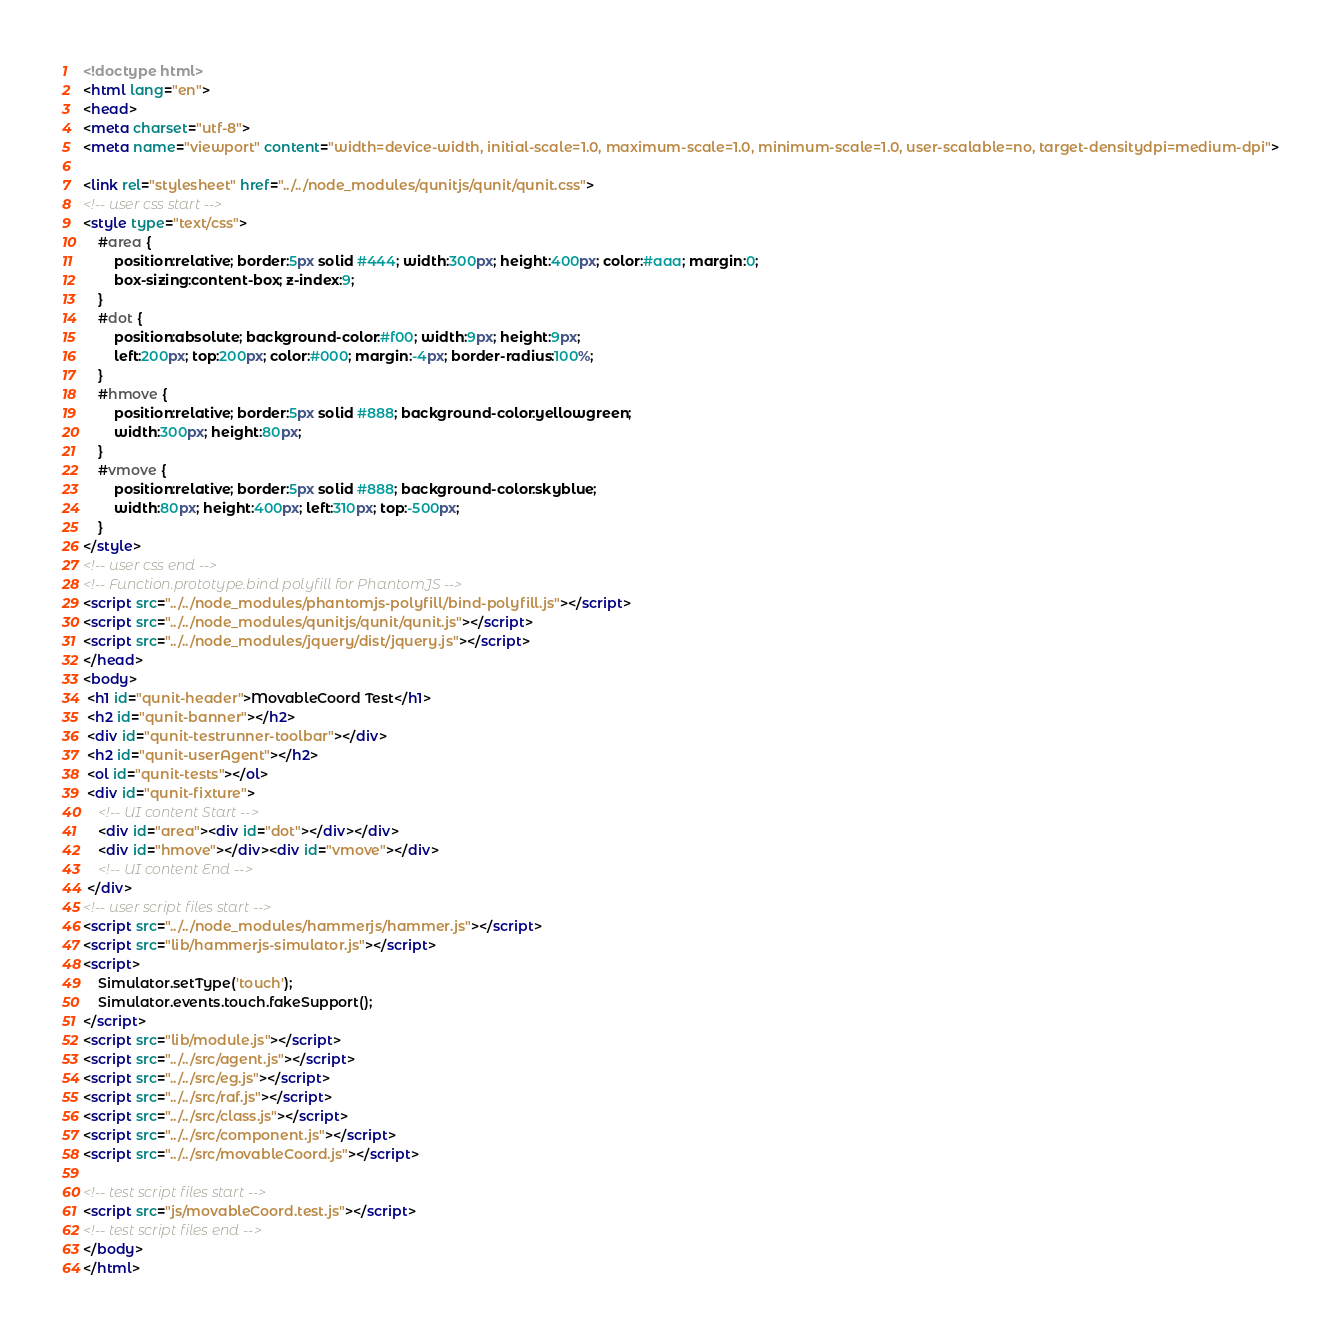<code> <loc_0><loc_0><loc_500><loc_500><_HTML_><!doctype html>
<html lang="en">
<head>
<meta charset="utf-8">
<meta name="viewport" content="width=device-width, initial-scale=1.0, maximum-scale=1.0, minimum-scale=1.0, user-scalable=no, target-densitydpi=medium-dpi">

<link rel="stylesheet" href="../../node_modules/qunitjs/qunit/qunit.css">
<!-- user css start -->
<style type="text/css">
	#area {
		position:relative; border:5px solid #444; width:300px; height:400px; color:#aaa; margin:0;
		box-sizing:content-box; z-index:9;
	}
	#dot {
		position:absolute; background-color:#f00; width:9px; height:9px;
		left:200px; top:200px; color:#000; margin:-4px; border-radius:100%;
	}
	#hmove {
		position:relative; border:5px solid #888; background-color:yellowgreen;
		width:300px; height:80px;
	}
	#vmove {
		position:relative; border:5px solid #888; background-color:skyblue;
		width:80px; height:400px; left:310px; top:-500px;
	}
</style>
<!-- user css end -->
<!-- Function.prototype.bind polyfill for PhantomJS -->
<script src="../../node_modules/phantomjs-polyfill/bind-polyfill.js"></script>
<script src="../../node_modules/qunitjs/qunit/qunit.js"></script>
<script src="../../node_modules/jquery/dist/jquery.js"></script>
</head>
<body>
 <h1 id="qunit-header">MovableCoord Test</h1>
 <h2 id="qunit-banner"></h2>
 <div id="qunit-testrunner-toolbar"></div>
 <h2 id="qunit-userAgent"></h2>
 <ol id="qunit-tests"></ol>
 <div id="qunit-fixture">
	<!-- UI content Start -->
	<div id="area"><div id="dot"></div></div>
	<div id="hmove"></div><div id="vmove"></div>
	<!-- UI content End -->
 </div>
<!-- user script files start -->
<script src="../../node_modules/hammerjs/hammer.js"></script>
<script src="lib/hammerjs-simulator.js"></script>
<script>
    Simulator.setType('touch');
    Simulator.events.touch.fakeSupport();
</script>
<script src="lib/module.js"></script>
<script src="../../src/agent.js"></script>
<script src="../../src/eg.js"></script>
<script src="../../src/raf.js"></script>
<script src="../../src/class.js"></script>
<script src="../../src/component.js"></script>
<script src="../../src/movableCoord.js"></script>

<!-- test script files start -->
<script src="js/movableCoord.test.js"></script>
<!-- test script files end -->
</body>
</html>
</code> 